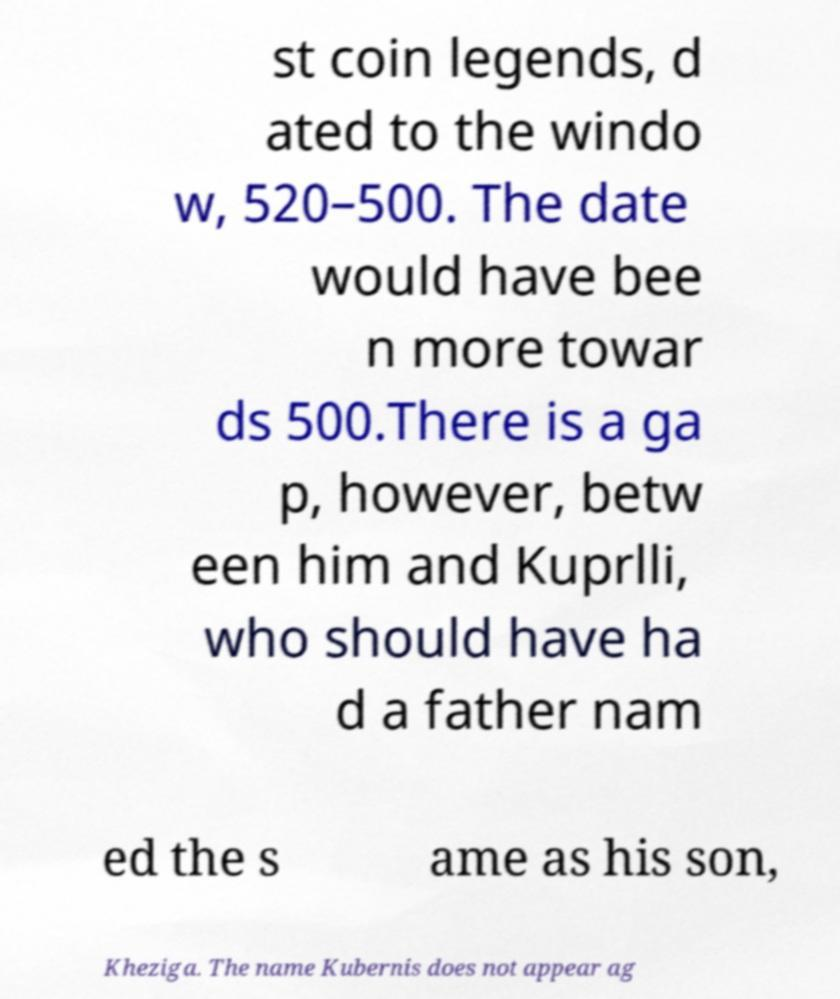There's text embedded in this image that I need extracted. Can you transcribe it verbatim? st coin legends, d ated to the windo w, 520–500. The date would have bee n more towar ds 500.There is a ga p, however, betw een him and Kuprlli, who should have ha d a father nam ed the s ame as his son, Kheziga. The name Kubernis does not appear ag 